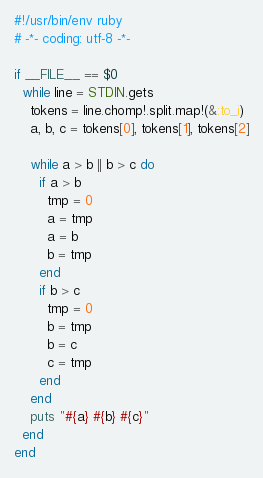Convert code to text. <code><loc_0><loc_0><loc_500><loc_500><_Ruby_>#!/usr/bin/env ruby
# -*- coding: utf-8 -*-
  
if __FILE__ == $0
  while line = STDIN.gets
    tokens = line.chomp!.split.map!(&:to_i)
    a, b, c = tokens[0], tokens[1], tokens[2]

    while a > b || b > c do
      if a > b
        tmp = 0
        a = tmp
        a = b
        b = tmp
      end
      if b > c
        tmp = 0
        b = tmp
        b = c
        c = tmp
      end
    end
    puts "#{a} #{b} #{c}"
  end
end</code> 